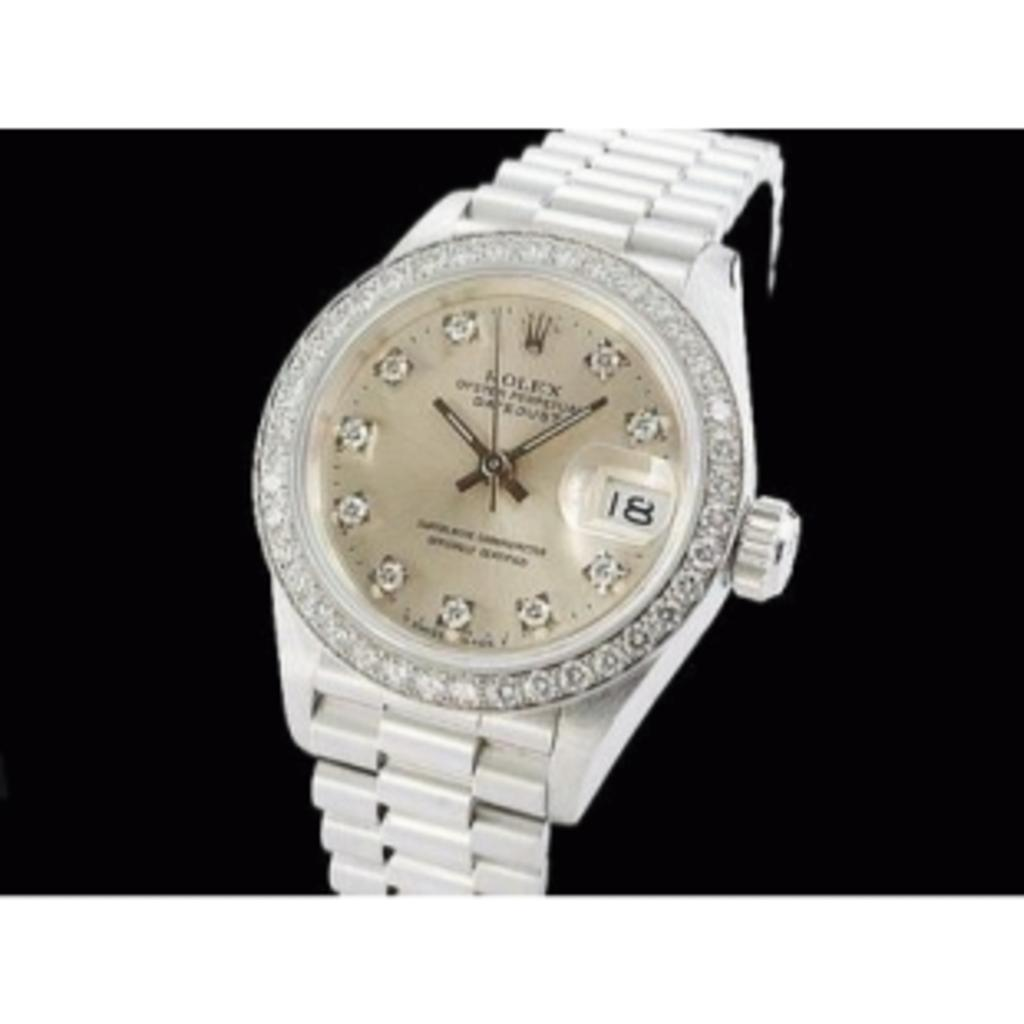<image>
Create a compact narrative representing the image presented. A silver and jewel encrusted Rolex watch that shows it being seven after ten. 